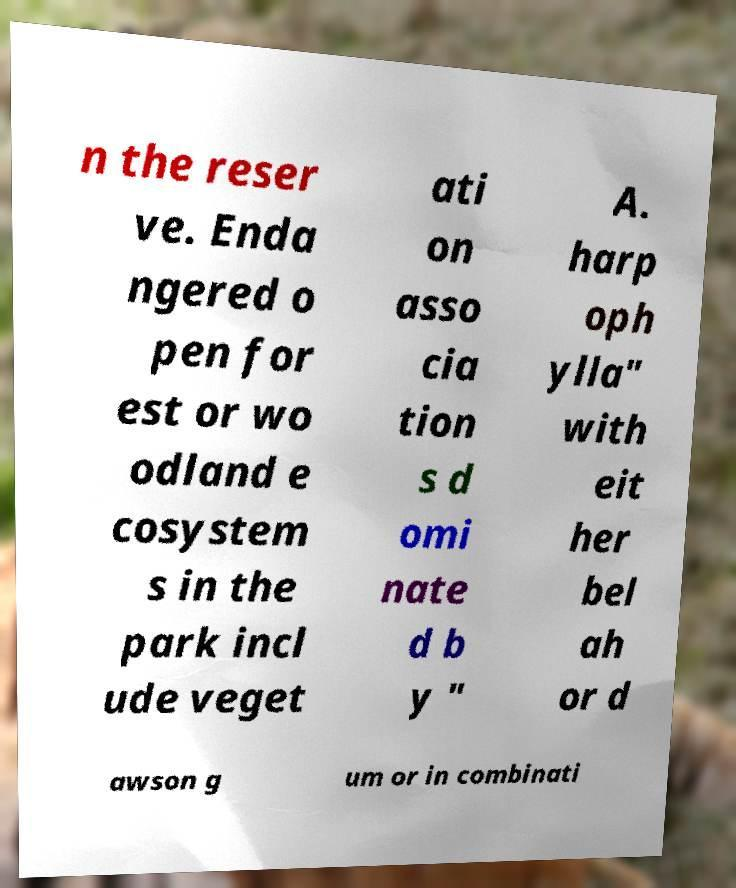There's text embedded in this image that I need extracted. Can you transcribe it verbatim? n the reser ve. Enda ngered o pen for est or wo odland e cosystem s in the park incl ude veget ati on asso cia tion s d omi nate d b y " A. harp oph ylla" with eit her bel ah or d awson g um or in combinati 